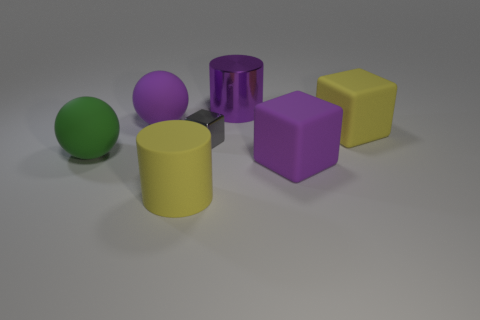Subtract all red balls. Subtract all red cubes. How many balls are left? 2 Add 2 large purple spheres. How many objects exist? 9 Subtract all blocks. How many objects are left? 4 Subtract 0 red cylinders. How many objects are left? 7 Subtract all tiny purple blocks. Subtract all cylinders. How many objects are left? 5 Add 4 cubes. How many cubes are left? 7 Add 3 metallic cylinders. How many metallic cylinders exist? 4 